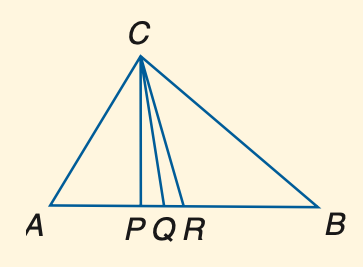Answer the mathemtical geometry problem and directly provide the correct option letter.
Question: In the figure, C P is an altitude, C Q is the angle bisector of \angle A C B, and R is the midpoint of A B. Find x if m \angle A P C = 72 + x.
Choices: A: 12 B: 15 C: 16 D: 18 D 